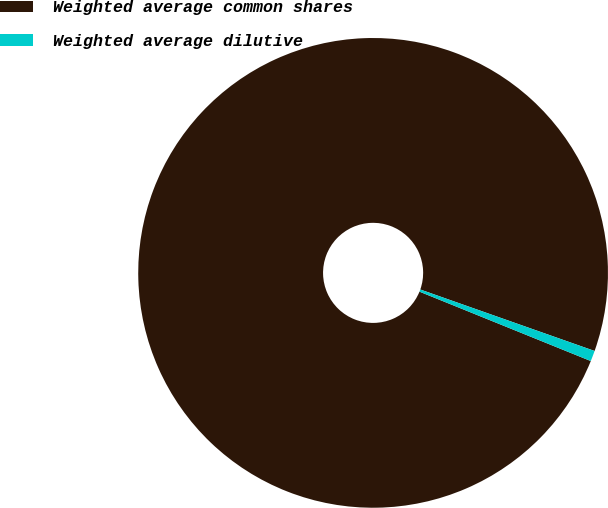<chart> <loc_0><loc_0><loc_500><loc_500><pie_chart><fcel>Weighted average common shares<fcel>Weighted average dilutive<nl><fcel>99.27%<fcel>0.73%<nl></chart> 